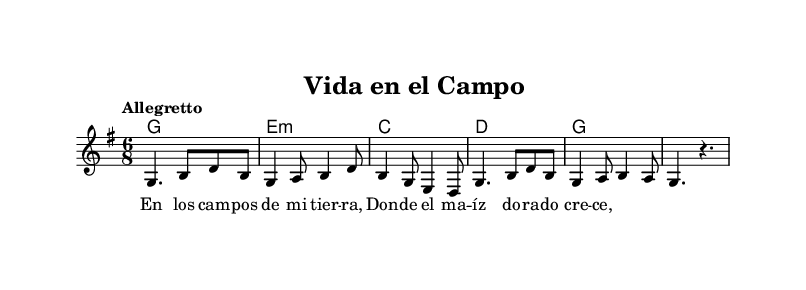What is the key signature of this music? The key signature is G major, which has one sharp (F#). This can be identified in the key signature section at the beginning of the score.
Answer: G major What is the time signature of this music? The time signature is 6/8, which is indicated at the beginning of the score. It suggests a compound meter with six eighth notes per measure.
Answer: 6/8 What is the tempo marking of this piece? The tempo marking is "Allegretto". This is specified above the staff, indicating a moderate tempo.
Answer: Allegretto How many measures does the melody have? The melody has six measures. By counting the distinct groups of notes and bar lines, you can see there are six complete measures in total.
Answer: 6 What chord is played in the first measure? The chord in the first measure is G major. This is determined by looking at the chord names above the melody corresponding to the first measure.
Answer: G major Describe the primary theme of the lyrics. The primary theme of the lyrics reflects life in rural areas, as it talks about fields and maize. This can be inferred from the content of the lyrics seen in the verse section.
Answer: Rural life What musical form does this piece primarily represent? The piece primarily represents a verse-chorus form, as indicated by the repetitive structure of the melody and lyrics. This can typically be identified by the presence of repeating phrases in folk music.
Answer: Verse-chorus 